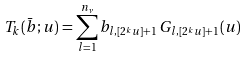<formula> <loc_0><loc_0><loc_500><loc_500>T _ { k } ( \bar { b } ; u ) = \sum _ { l = 1 } ^ { n _ { \nu } } b _ { l , [ 2 ^ { k } u ] + 1 } \, G _ { l , [ 2 ^ { k } u ] + 1 } ( u )</formula> 